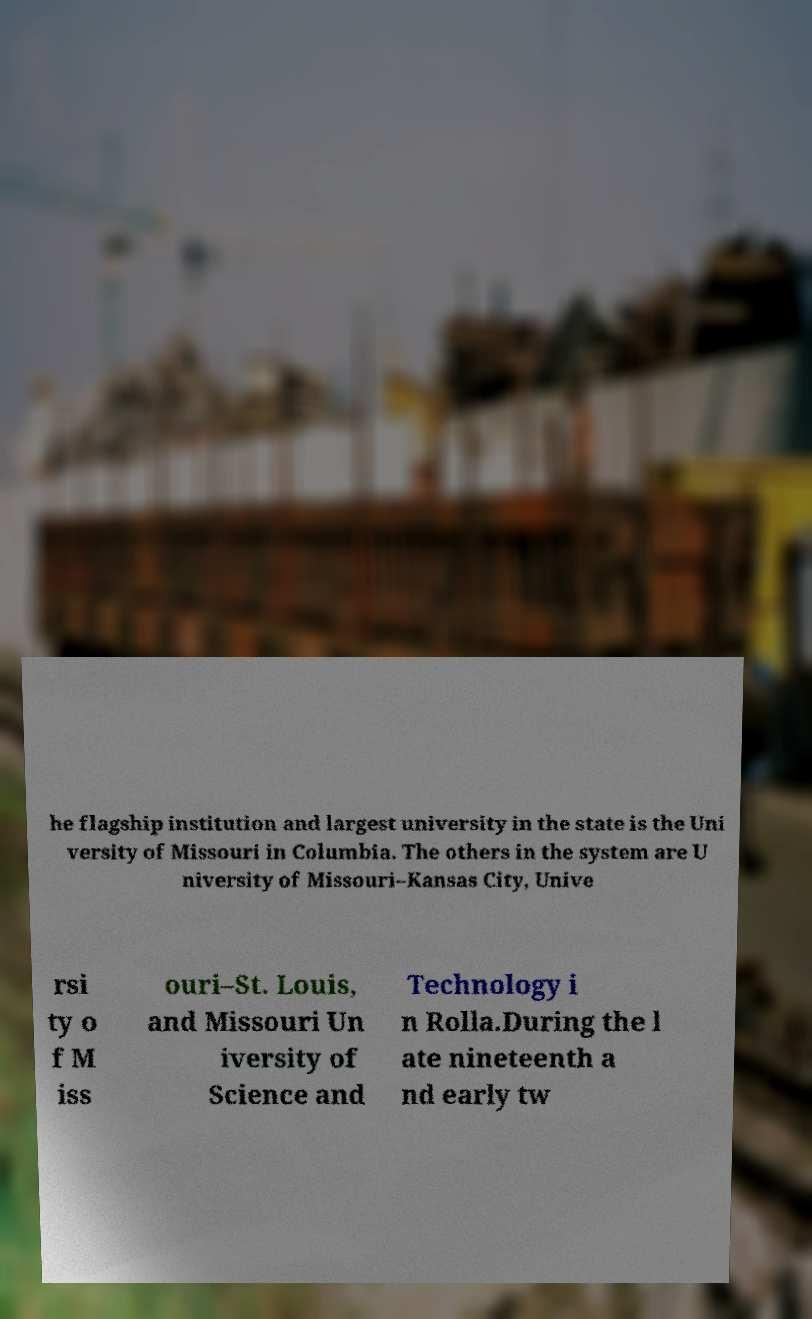I need the written content from this picture converted into text. Can you do that? he flagship institution and largest university in the state is the Uni versity of Missouri in Columbia. The others in the system are U niversity of Missouri–Kansas City, Unive rsi ty o f M iss ouri–St. Louis, and Missouri Un iversity of Science and Technology i n Rolla.During the l ate nineteenth a nd early tw 